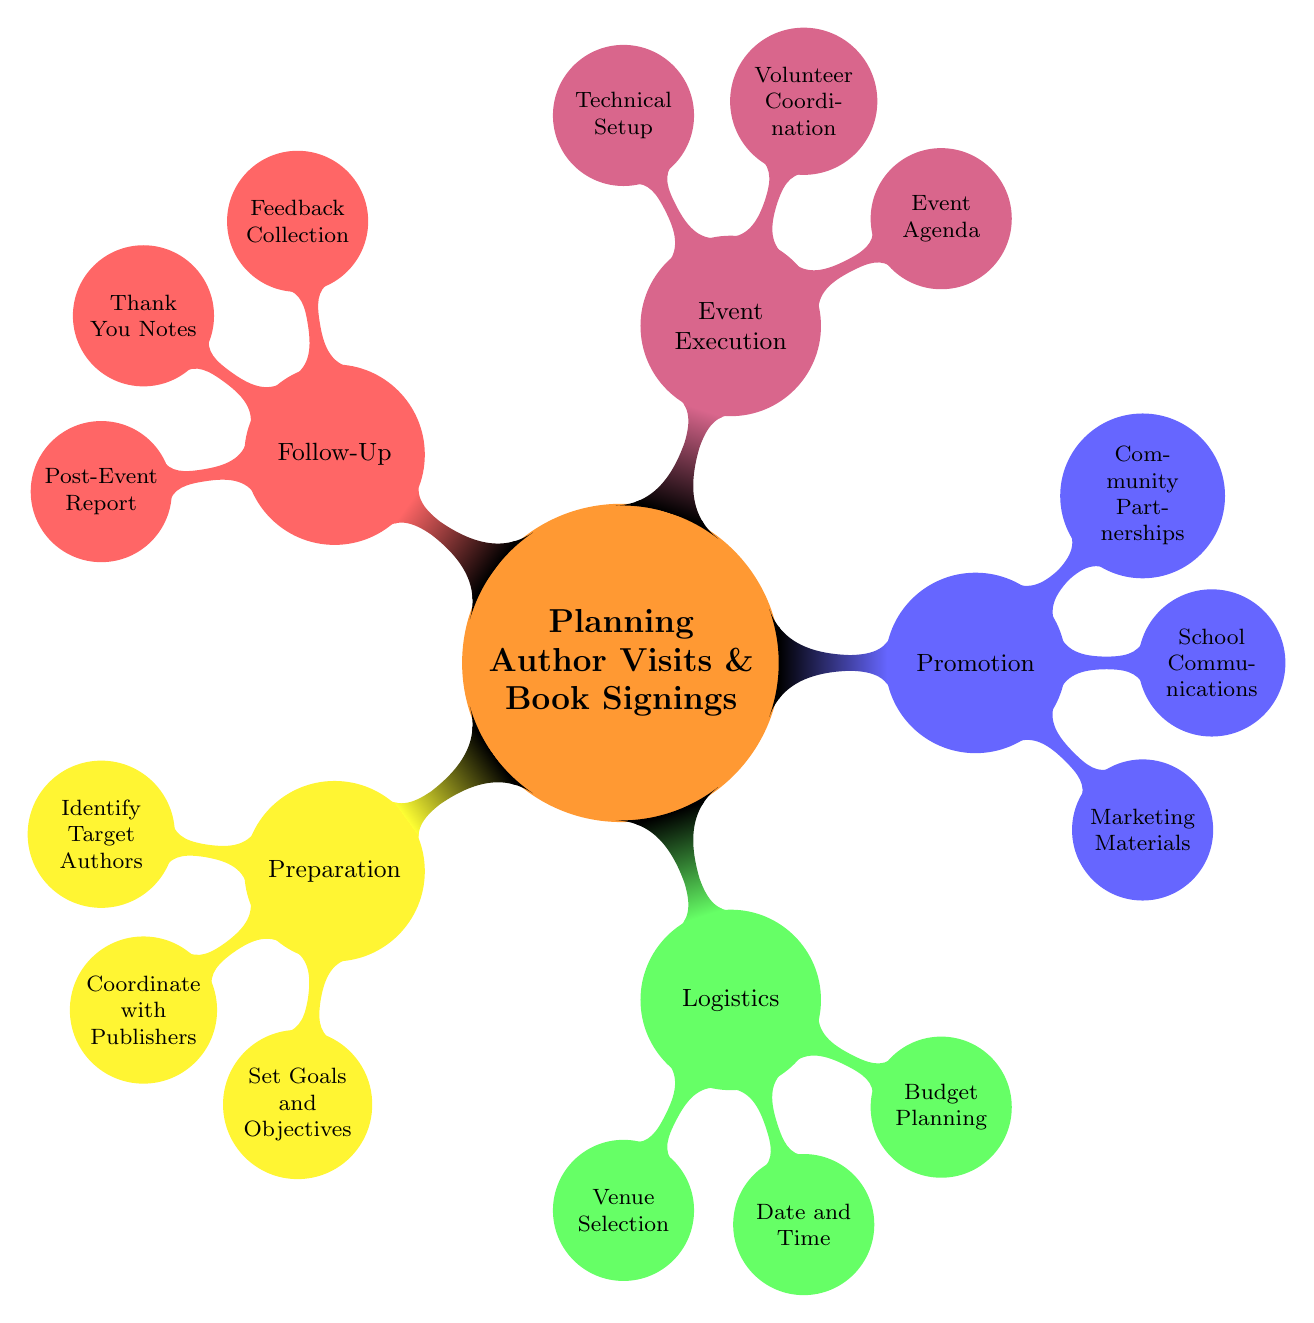What is the main topic of the mind map? The central node of the mind map is labeled "Planning Author Visits & Book Signings," which indicates the primary focus of the entire diagram.
Answer: Planning Author Visits & Book Signings How many main categories are there in the mind map? The diagram includes five main categories branching out from the central topic: Preparation, Logistics, Promotion, Event Execution, and Follow-Up. Counting these, we find there are five.
Answer: 5 Which category contains "Budget Planning"? "Budget Planning" is listed as a sub-node under the "Logistics" category, indicating that it is related to the logistical aspects of organizing author visits and book signings.
Answer: Logistics What are two elements listed under "Promotion"? The "Promotion" category contains several sub-nodes, including "Marketing Materials" and "School Communications." These help describe ways to promote author visits and book signings.
Answer: Marketing Materials, School Communications What is the purpose of "Feedback Collection"? "Feedback Collection" falls under the "Follow-Up" category, indicating it is aimed at gathering responses after the event to assess the event's success and areas for improvement.
Answer: To collect responses after the event Which sub-node appears under "Event Execution"? There are three sub-nodes under "Event Execution," one of which is "Volunteer Coordination." This shows the importance of managing volunteers during the event execution phase.
Answer: Volunteer Coordination How many types of target authors are identified in the "Preparation" category? Within the "Preparation" category, three types of target authors are specified: Local Authors, Popular Children’s Authors, and Young Adult Fiction Authors, hence there are three distinct types.
Answer: 3 What is one form of marketing material suggested in the diagram? Under the "Promotion" category, "Posters" is listed as one of the suggested marketing materials to promote author visits and book signings, contributing to the overall effort of reaching a wider audience.
Answer: Posters What is a key objective mentioned in the "Preparation" category? The "Preparation" category lists "Increase Student Engagement" as one key objective, which indicates a focus on making the author visits impactful for the students.
Answer: Increase Student Engagement 